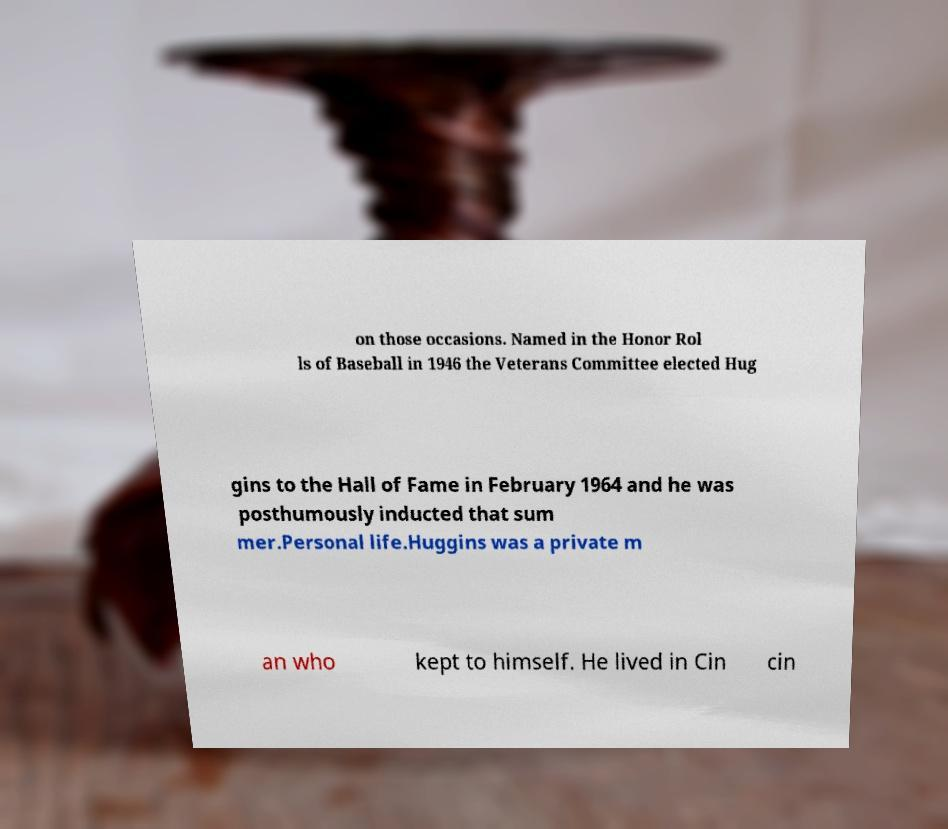Please read and relay the text visible in this image. What does it say? on those occasions. Named in the Honor Rol ls of Baseball in 1946 the Veterans Committee elected Hug gins to the Hall of Fame in February 1964 and he was posthumously inducted that sum mer.Personal life.Huggins was a private m an who kept to himself. He lived in Cin cin 